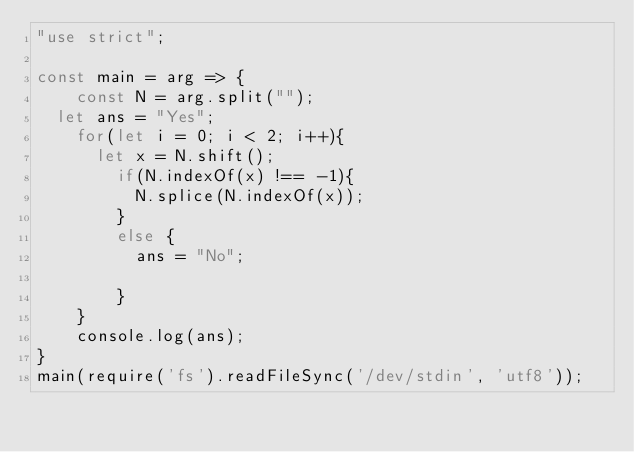Convert code to text. <code><loc_0><loc_0><loc_500><loc_500><_JavaScript_>"use strict";
    
const main = arg => {
    const N = arg.split("");
	let ans = "Yes";
  	for(let i = 0; i < 2; i++){
    	let x = N.shift();
      	if(N.indexOf(x) !== -1){
      		N.splice(N.indexOf(x));
        }
      	else {
        	ans = "No";
          	
        }
    }
  	console.log(ans);
}
main(require('fs').readFileSync('/dev/stdin', 'utf8'));
</code> 